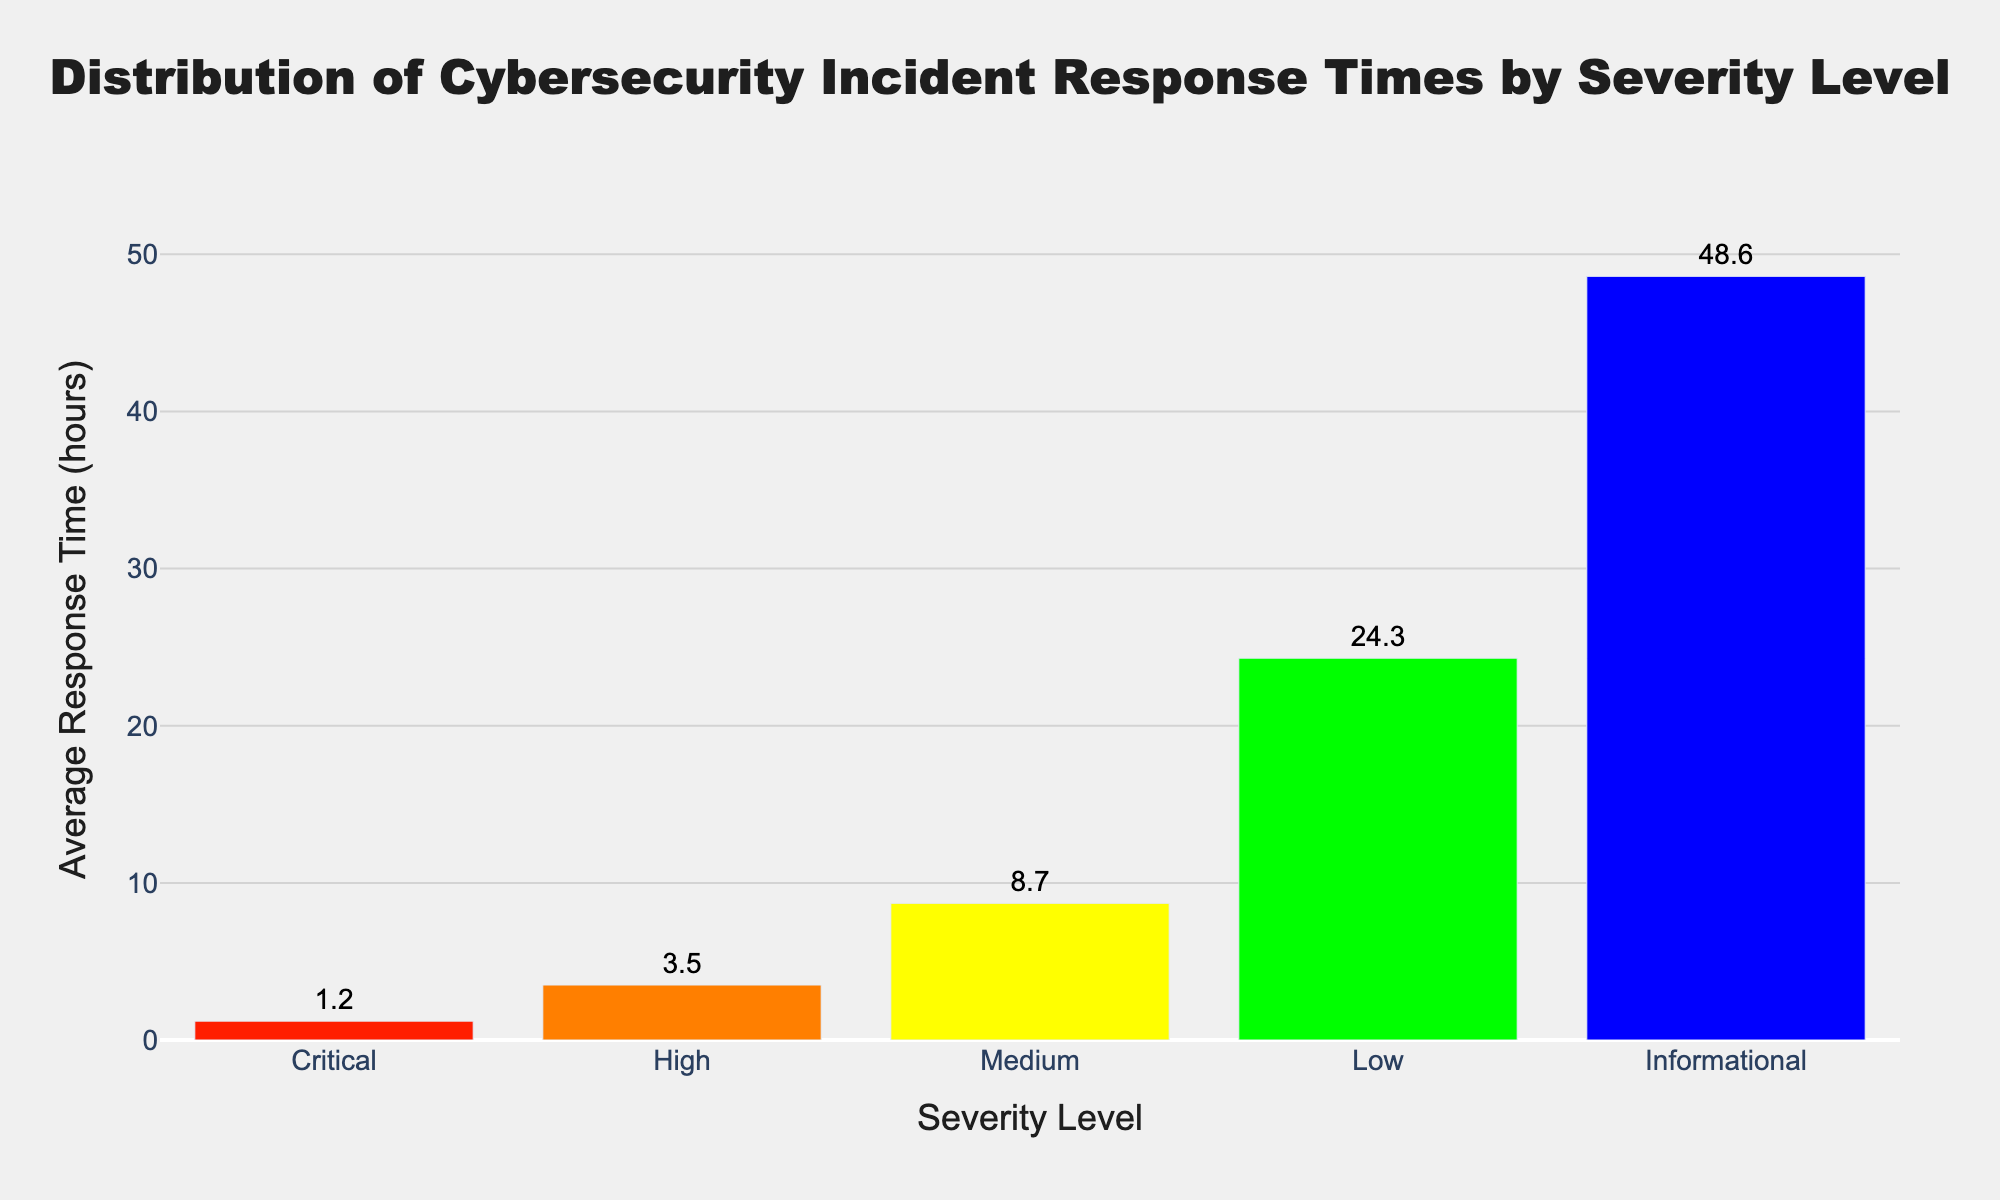What is the average response time for a Critical severity level incident? The bar corresponding to the Critical severity level indicates the average response time is 1.2 hours.
Answer: 1.2 hours Which severity level has the longest average response time? By comparing the heights of all bars, the Informational severity level has the longest average response time of 48.6 hours.
Answer: Informational What is the difference in average response time between the Critical and Medium severity levels? The average response time for Critical is 1.2 hours, and for Medium, it is 8.7 hours. The difference is 8.7 - 1.2 = 7.5 hours.
Answer: 7.5 hours What is the sum of the average response times for High and Low severity levels? The average response time for High is 3.5 hours and for Low, it is 24.3 hours. The sum is 3.5 + 24.3 = 27.8 hours.
Answer: 27.8 hours Which severity level has an average response time that is closest to 10 hours? By examining the bars, the Medium severity level has an average response time of 8.7 hours, which is closest to 10 hours.
Answer: Medium Are there any severity levels with average response times under 5 hours? The bars for Critical and High severity levels show average response times of 1.2 hours and 3.5 hours, respectively, both under 5 hours.
Answer: Yes, Critical and High What is the average response time across all severity levels? Sum all average response times (1.2 + 3.5 + 8.7 + 24.3 + 48.6 = 86.3) and divide this by the number of severity levels (5). The average is 86.3 / 5 = 17.26 hours.
Answer: 17.26 hours How many severity levels have an average response time greater than 20 hours? By inspecting the bars, the Low (24.3 hours) and Informational (48.6 hours) severity levels have average response times greater than 20 hours.
Answer: 2 Is the average response time for Informational incidents more than double that for Medium incidents? The average response time for Informational incidents is 48.6 hours, and for Medium, it is 8.7 hours. Doubling 8.7 gives 17.4, and 48.6 is indeed more than double 8.7.
Answer: Yes What is the ratio of the average response time for High severity to that of Informational severity? The average response time for High is 3.5 hours, and for Informational, it is 48.6 hours. The ratio is 3.5 / 48.6 ≈ 0.072.
Answer: 0.072 